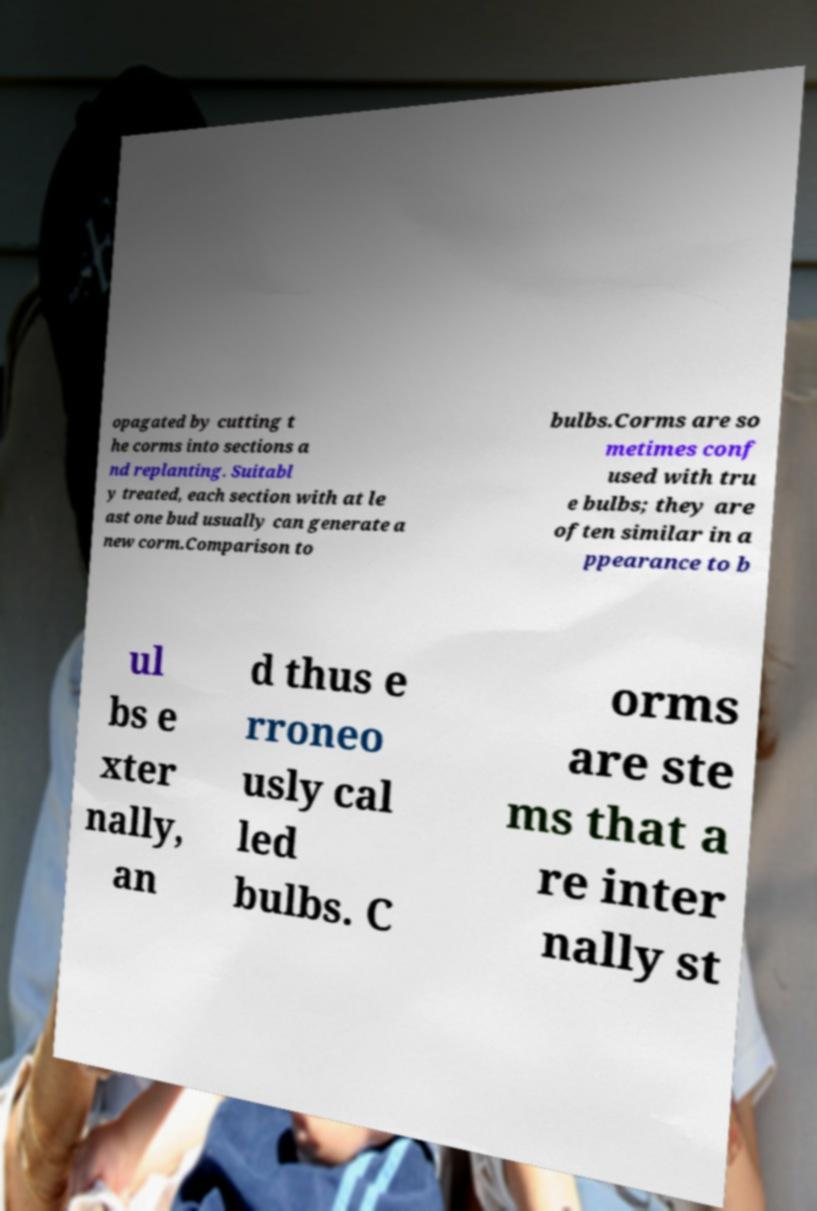What messages or text are displayed in this image? I need them in a readable, typed format. opagated by cutting t he corms into sections a nd replanting. Suitabl y treated, each section with at le ast one bud usually can generate a new corm.Comparison to bulbs.Corms are so metimes conf used with tru e bulbs; they are often similar in a ppearance to b ul bs e xter nally, an d thus e rroneo usly cal led bulbs. C orms are ste ms that a re inter nally st 